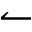Convert formula to latex. <formula><loc_0><loc_0><loc_500><loc_500>\leftharpoonup</formula> 